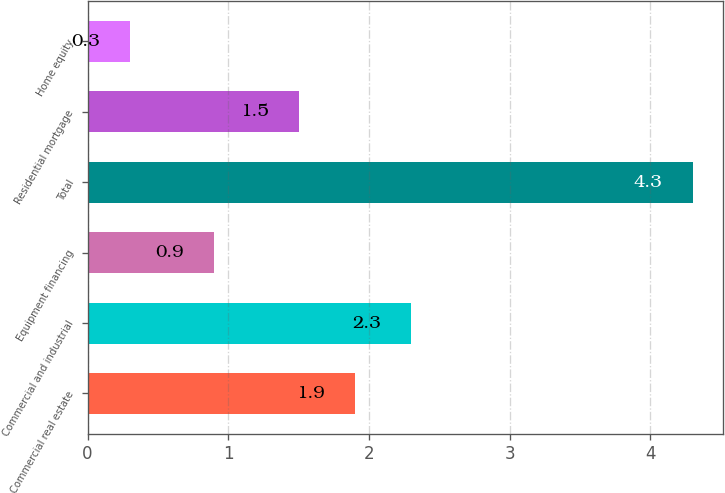<chart> <loc_0><loc_0><loc_500><loc_500><bar_chart><fcel>Commercial real estate<fcel>Commercial and industrial<fcel>Equipment financing<fcel>Total<fcel>Residential mortgage<fcel>Home equity<nl><fcel>1.9<fcel>2.3<fcel>0.9<fcel>4.3<fcel>1.5<fcel>0.3<nl></chart> 